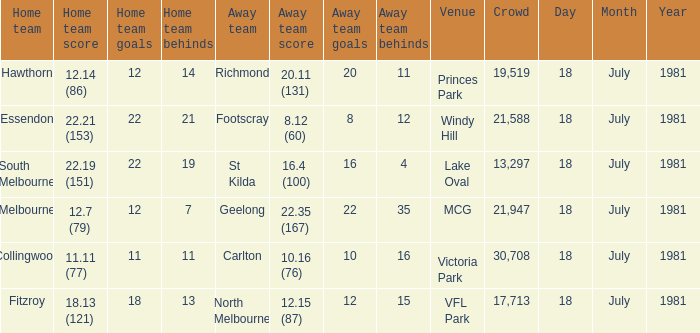On what date was the Essendon home match? 18 July 1981. 